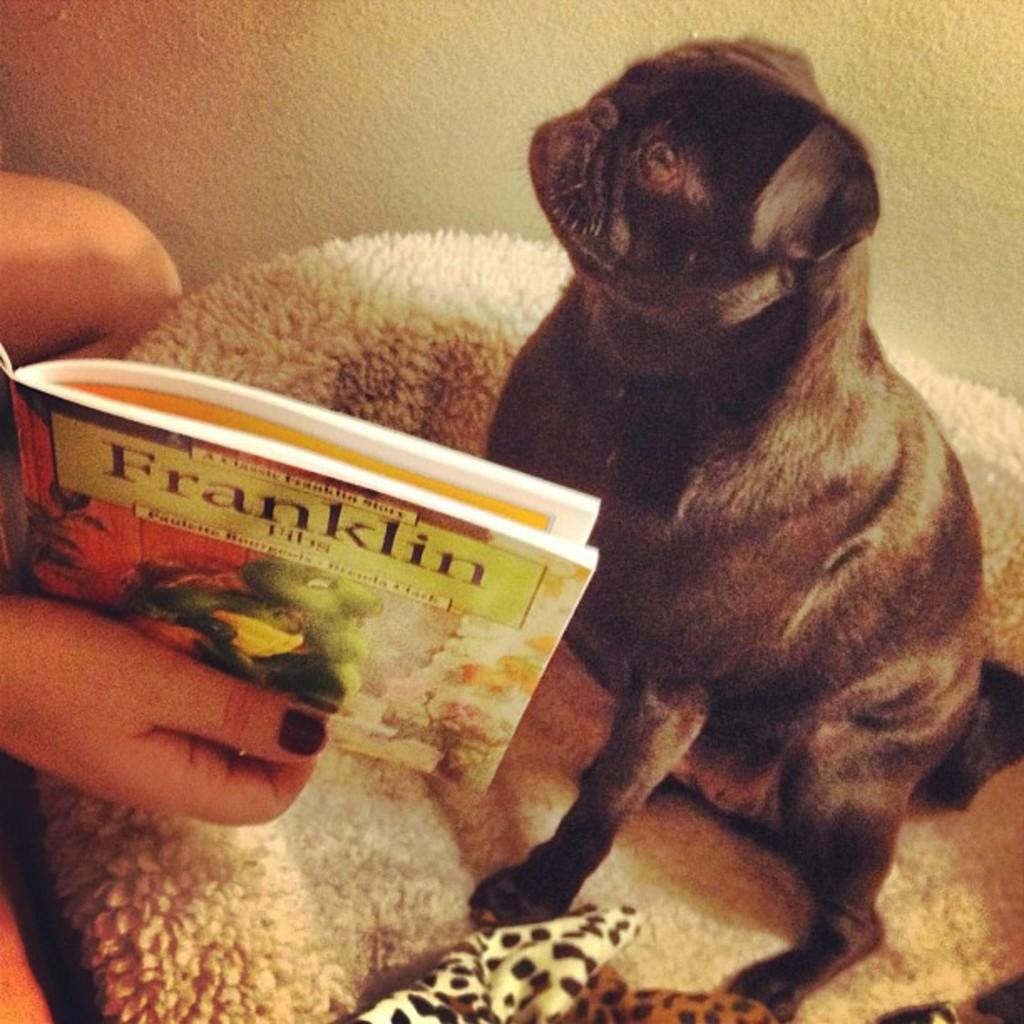What type of animal can be seen in the image? There is a dog in the image. What is the person on the left side of the image doing? The person is holding a book. What can be seen at the bottom of the image? There is furniture at the bottom of the image. What is visible in the background of the image? There is a wall in the background of the image. How many trucks are parked in front of the wall in the image? There are no trucks present in the image; it features a dog, a person holding a book, furniture, and a wall. What type of apparatus is being used by the dog in the image? There is no apparatus being used by the dog in the image; it is simply a dog sitting or standing. 